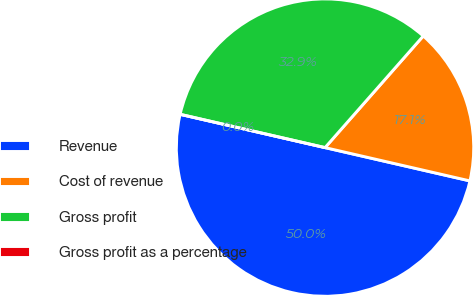Convert chart to OTSL. <chart><loc_0><loc_0><loc_500><loc_500><pie_chart><fcel>Revenue<fcel>Cost of revenue<fcel>Gross profit<fcel>Gross profit as a percentage<nl><fcel>50.0%<fcel>17.11%<fcel>32.89%<fcel>0.0%<nl></chart> 